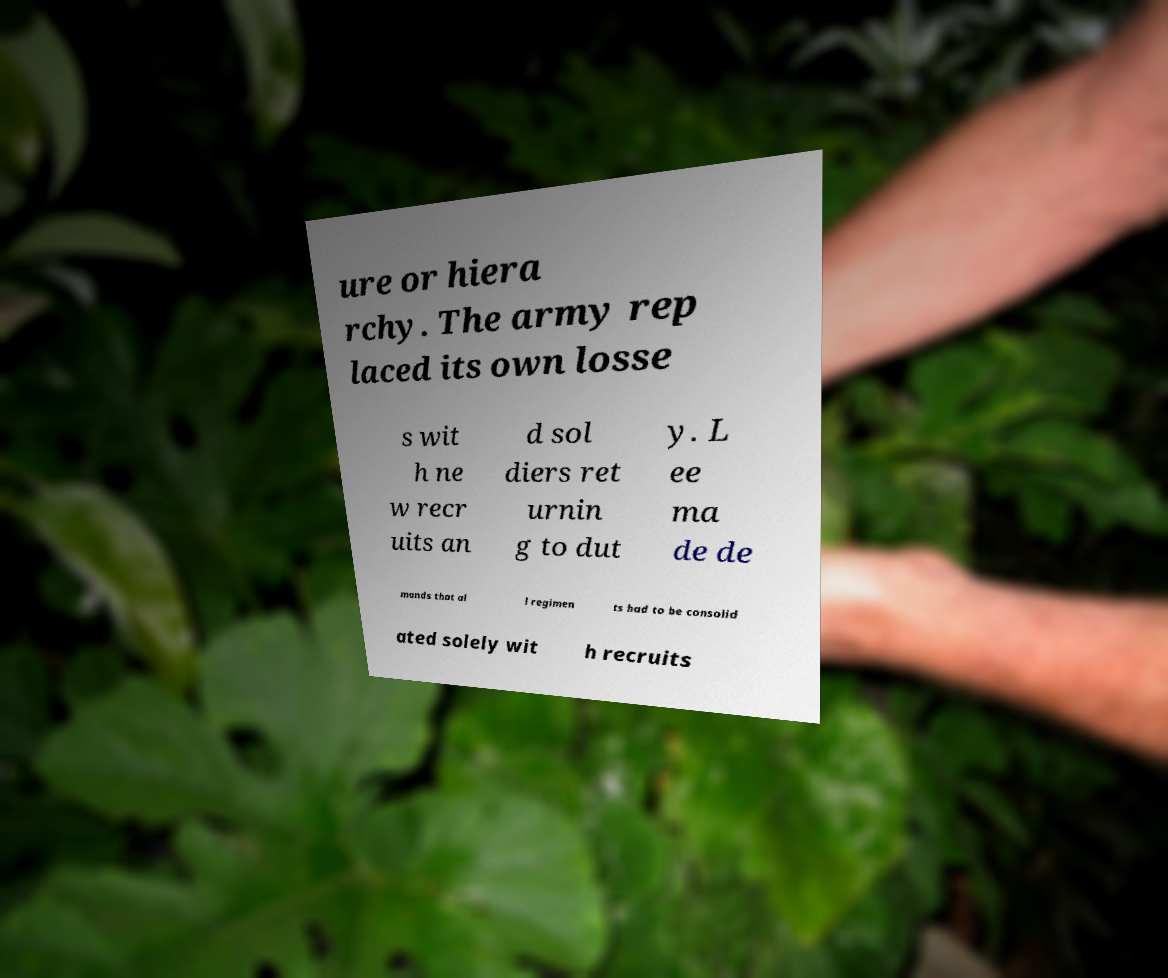I need the written content from this picture converted into text. Can you do that? ure or hiera rchy. The army rep laced its own losse s wit h ne w recr uits an d sol diers ret urnin g to dut y. L ee ma de de mands that al l regimen ts had to be consolid ated solely wit h recruits 